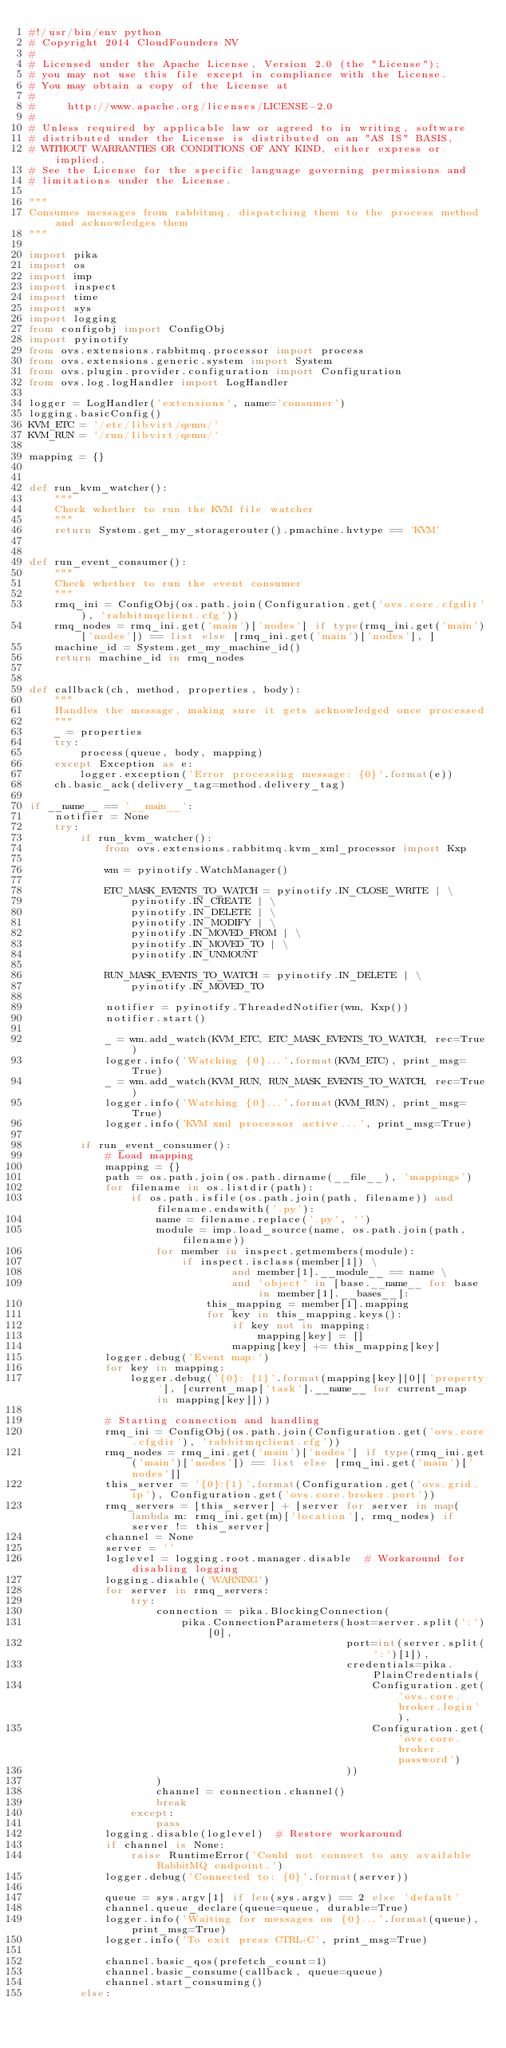Convert code to text. <code><loc_0><loc_0><loc_500><loc_500><_Python_>#!/usr/bin/env python
# Copyright 2014 CloudFounders NV
#
# Licensed under the Apache License, Version 2.0 (the "License");
# you may not use this file except in compliance with the License.
# You may obtain a copy of the License at
#
#     http://www.apache.org/licenses/LICENSE-2.0
#
# Unless required by applicable law or agreed to in writing, software
# distributed under the License is distributed on an "AS IS" BASIS,
# WITHOUT WARRANTIES OR CONDITIONS OF ANY KIND, either express or implied.
# See the License for the specific language governing permissions and
# limitations under the License.

"""
Consumes messages from rabbitmq, dispatching them to the process method and acknowledges them
"""

import pika
import os
import imp
import inspect
import time
import sys
import logging
from configobj import ConfigObj
import pyinotify
from ovs.extensions.rabbitmq.processor import process
from ovs.extensions.generic.system import System
from ovs.plugin.provider.configuration import Configuration
from ovs.log.logHandler import LogHandler

logger = LogHandler('extensions', name='consumer')
logging.basicConfig()
KVM_ETC = '/etc/libvirt/qemu/'
KVM_RUN = '/run/libvirt/qemu/'

mapping = {}


def run_kvm_watcher():
    """
    Check whether to run the KVM file watcher
    """
    return System.get_my_storagerouter().pmachine.hvtype == 'KVM'


def run_event_consumer():
    """
    Check whether to run the event consumer
    """
    rmq_ini = ConfigObj(os.path.join(Configuration.get('ovs.core.cfgdir'), 'rabbitmqclient.cfg'))
    rmq_nodes = rmq_ini.get('main')['nodes'] if type(rmq_ini.get('main')['nodes']) == list else [rmq_ini.get('main')['nodes'], ]
    machine_id = System.get_my_machine_id()
    return machine_id in rmq_nodes


def callback(ch, method, properties, body):
    """
    Handles the message, making sure it gets acknowledged once processed
    """
    _ = properties
    try:
        process(queue, body, mapping)
    except Exception as e:
        logger.exception('Error processing message: {0}'.format(e))
    ch.basic_ack(delivery_tag=method.delivery_tag)

if __name__ == '__main__':
    notifier = None
    try:
        if run_kvm_watcher():
            from ovs.extensions.rabbitmq.kvm_xml_processor import Kxp

            wm = pyinotify.WatchManager()

            ETC_MASK_EVENTS_TO_WATCH = pyinotify.IN_CLOSE_WRITE | \
                pyinotify.IN_CREATE | \
                pyinotify.IN_DELETE | \
                pyinotify.IN_MODIFY | \
                pyinotify.IN_MOVED_FROM | \
                pyinotify.IN_MOVED_TO | \
                pyinotify.IN_UNMOUNT

            RUN_MASK_EVENTS_TO_WATCH = pyinotify.IN_DELETE | \
                pyinotify.IN_MOVED_TO

            notifier = pyinotify.ThreadedNotifier(wm, Kxp())
            notifier.start()

            _ = wm.add_watch(KVM_ETC, ETC_MASK_EVENTS_TO_WATCH, rec=True)
            logger.info('Watching {0}...'.format(KVM_ETC), print_msg=True)
            _ = wm.add_watch(KVM_RUN, RUN_MASK_EVENTS_TO_WATCH, rec=True)
            logger.info('Watching {0}...'.format(KVM_RUN), print_msg=True)
            logger.info('KVM xml processor active...', print_msg=True)

        if run_event_consumer():
            # Load mapping
            mapping = {}
            path = os.path.join(os.path.dirname(__file__), 'mappings')
            for filename in os.listdir(path):
                if os.path.isfile(os.path.join(path, filename)) and filename.endswith('.py'):
                    name = filename.replace('.py', '')
                    module = imp.load_source(name, os.path.join(path, filename))
                    for member in inspect.getmembers(module):
                        if inspect.isclass(member[1]) \
                                and member[1].__module__ == name \
                                and 'object' in [base.__name__ for base in member[1].__bases__]:
                            this_mapping = member[1].mapping
                            for key in this_mapping.keys():
                                if key not in mapping:
                                    mapping[key] = []
                                mapping[key] += this_mapping[key]
            logger.debug('Event map:')
            for key in mapping:
                logger.debug('{0}: {1}'.format(mapping[key][0]['property'], [current_map['task'].__name__ for current_map in mapping[key]]))

            # Starting connection and handling
            rmq_ini = ConfigObj(os.path.join(Configuration.get('ovs.core.cfgdir'), 'rabbitmqclient.cfg'))
            rmq_nodes = rmq_ini.get('main')['nodes'] if type(rmq_ini.get('main')['nodes']) == list else [rmq_ini.get('main')['nodes']]
            this_server = '{0}:{1}'.format(Configuration.get('ovs.grid.ip'), Configuration.get('ovs.core.broker.port'))
            rmq_servers = [this_server] + [server for server in map(lambda m: rmq_ini.get(m)['location'], rmq_nodes) if server != this_server]
            channel = None
            server = ''
            loglevel = logging.root.manager.disable  # Workaround for disabling logging
            logging.disable('WARNING')
            for server in rmq_servers:
                try:
                    connection = pika.BlockingConnection(
                        pika.ConnectionParameters(host=server.split(':')[0],
                                                  port=int(server.split(':')[1]),
                                                  credentials=pika.PlainCredentials(
                                                      Configuration.get('ovs.core.broker.login'),
                                                      Configuration.get('ovs.core.broker.password')
                                                  ))
                    )
                    channel = connection.channel()
                    break
                except:
                    pass
            logging.disable(loglevel)  # Restore workaround
            if channel is None:
                raise RuntimeError('Could not connect to any available RabbitMQ endpoint.')
            logger.debug('Connected to: {0}'.format(server))

            queue = sys.argv[1] if len(sys.argv) == 2 else 'default'
            channel.queue_declare(queue=queue, durable=True)
            logger.info('Waiting for messages on {0}...'.format(queue), print_msg=True)
            logger.info('To exit press CTRL+C', print_msg=True)

            channel.basic_qos(prefetch_count=1)
            channel.basic_consume(callback, queue=queue)
            channel.start_consuming()
        else:</code> 